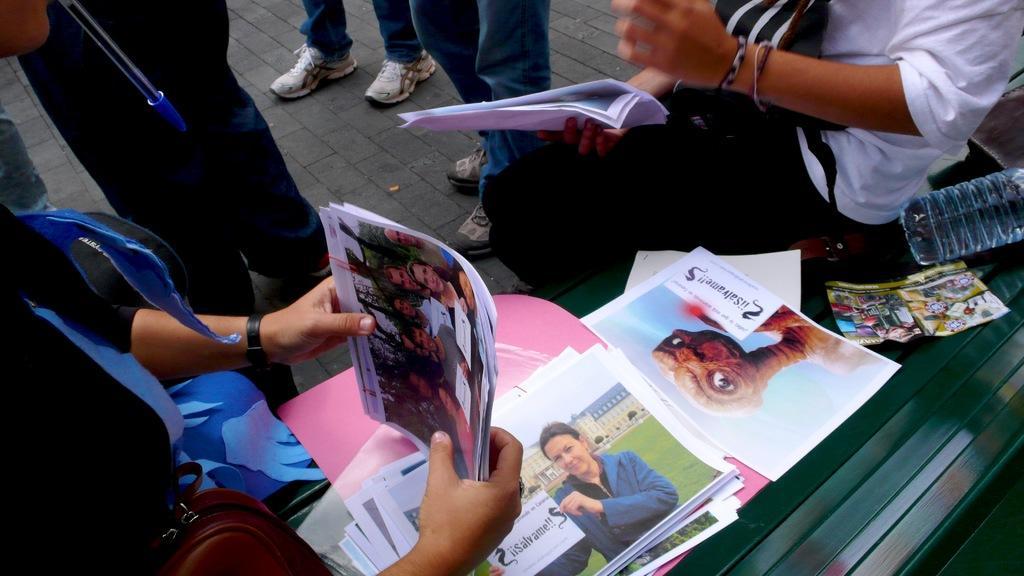How would you summarize this image in a sentence or two? In this image we can see some persons standing on the road and some are sitting on the bench. The persons are holding papers in their hands and there are disposable bottles, books, papers on the bench. 